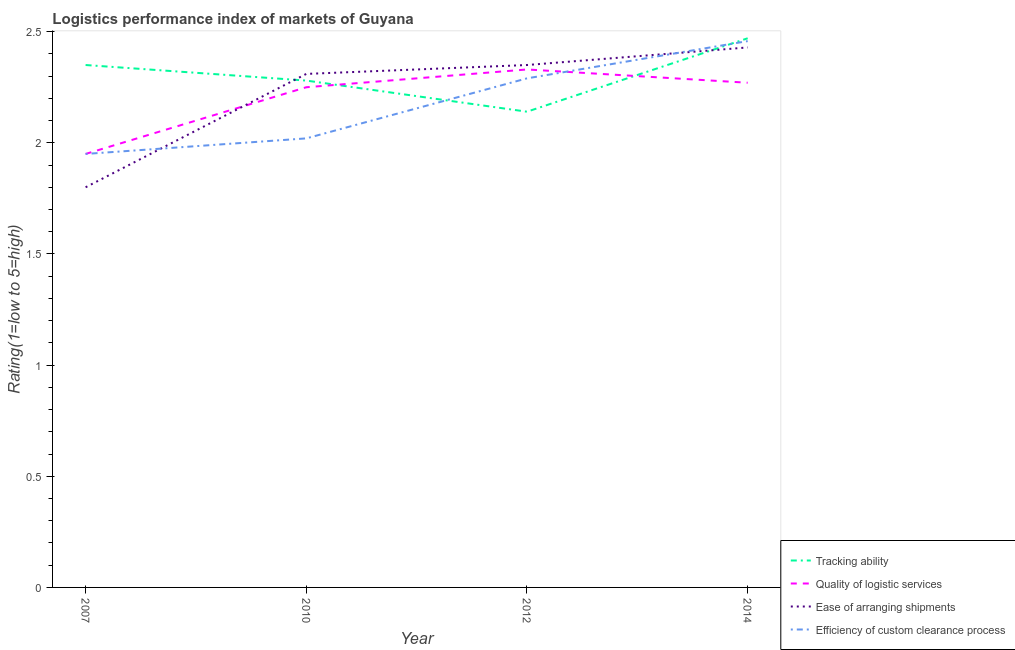What is the lpi rating of quality of logistic services in 2007?
Provide a succinct answer. 1.95. Across all years, what is the maximum lpi rating of efficiency of custom clearance process?
Your answer should be compact. 2.46. Across all years, what is the minimum lpi rating of efficiency of custom clearance process?
Offer a very short reply. 1.95. In which year was the lpi rating of efficiency of custom clearance process maximum?
Your response must be concise. 2014. In which year was the lpi rating of quality of logistic services minimum?
Offer a terse response. 2007. What is the total lpi rating of ease of arranging shipments in the graph?
Offer a very short reply. 8.89. What is the difference between the lpi rating of efficiency of custom clearance process in 2007 and that in 2012?
Keep it short and to the point. -0.34. What is the difference between the lpi rating of efficiency of custom clearance process in 2014 and the lpi rating of tracking ability in 2010?
Your response must be concise. 0.18. What is the average lpi rating of ease of arranging shipments per year?
Provide a short and direct response. 2.22. In the year 2010, what is the difference between the lpi rating of tracking ability and lpi rating of ease of arranging shipments?
Offer a very short reply. -0.03. What is the ratio of the lpi rating of ease of arranging shipments in 2007 to that in 2012?
Your answer should be compact. 0.77. Is the lpi rating of efficiency of custom clearance process in 2012 less than that in 2014?
Offer a terse response. Yes. Is the difference between the lpi rating of quality of logistic services in 2007 and 2014 greater than the difference between the lpi rating of ease of arranging shipments in 2007 and 2014?
Give a very brief answer. Yes. What is the difference between the highest and the second highest lpi rating of quality of logistic services?
Your answer should be compact. 0.06. What is the difference between the highest and the lowest lpi rating of tracking ability?
Your answer should be very brief. 0.33. In how many years, is the lpi rating of quality of logistic services greater than the average lpi rating of quality of logistic services taken over all years?
Offer a terse response. 3. Is it the case that in every year, the sum of the lpi rating of tracking ability and lpi rating of quality of logistic services is greater than the lpi rating of ease of arranging shipments?
Offer a very short reply. Yes. Does the lpi rating of efficiency of custom clearance process monotonically increase over the years?
Give a very brief answer. Yes. What is the difference between two consecutive major ticks on the Y-axis?
Provide a succinct answer. 0.5. Does the graph contain grids?
Offer a very short reply. No. Where does the legend appear in the graph?
Your answer should be compact. Bottom right. How many legend labels are there?
Your answer should be very brief. 4. How are the legend labels stacked?
Give a very brief answer. Vertical. What is the title of the graph?
Ensure brevity in your answer.  Logistics performance index of markets of Guyana. What is the label or title of the Y-axis?
Your answer should be very brief. Rating(1=low to 5=high). What is the Rating(1=low to 5=high) of Tracking ability in 2007?
Give a very brief answer. 2.35. What is the Rating(1=low to 5=high) of Quality of logistic services in 2007?
Keep it short and to the point. 1.95. What is the Rating(1=low to 5=high) in Efficiency of custom clearance process in 2007?
Offer a very short reply. 1.95. What is the Rating(1=low to 5=high) of Tracking ability in 2010?
Your answer should be compact. 2.28. What is the Rating(1=low to 5=high) in Quality of logistic services in 2010?
Ensure brevity in your answer.  2.25. What is the Rating(1=low to 5=high) in Ease of arranging shipments in 2010?
Ensure brevity in your answer.  2.31. What is the Rating(1=low to 5=high) of Efficiency of custom clearance process in 2010?
Offer a very short reply. 2.02. What is the Rating(1=low to 5=high) in Tracking ability in 2012?
Give a very brief answer. 2.14. What is the Rating(1=low to 5=high) in Quality of logistic services in 2012?
Provide a short and direct response. 2.33. What is the Rating(1=low to 5=high) in Ease of arranging shipments in 2012?
Give a very brief answer. 2.35. What is the Rating(1=low to 5=high) in Efficiency of custom clearance process in 2012?
Give a very brief answer. 2.29. What is the Rating(1=low to 5=high) of Tracking ability in 2014?
Offer a terse response. 2.47. What is the Rating(1=low to 5=high) of Quality of logistic services in 2014?
Offer a terse response. 2.27. What is the Rating(1=low to 5=high) of Ease of arranging shipments in 2014?
Keep it short and to the point. 2.43. What is the Rating(1=low to 5=high) of Efficiency of custom clearance process in 2014?
Your answer should be very brief. 2.46. Across all years, what is the maximum Rating(1=low to 5=high) in Tracking ability?
Ensure brevity in your answer.  2.47. Across all years, what is the maximum Rating(1=low to 5=high) of Quality of logistic services?
Your response must be concise. 2.33. Across all years, what is the maximum Rating(1=low to 5=high) in Ease of arranging shipments?
Give a very brief answer. 2.43. Across all years, what is the maximum Rating(1=low to 5=high) of Efficiency of custom clearance process?
Ensure brevity in your answer.  2.46. Across all years, what is the minimum Rating(1=low to 5=high) of Tracking ability?
Provide a succinct answer. 2.14. Across all years, what is the minimum Rating(1=low to 5=high) of Quality of logistic services?
Give a very brief answer. 1.95. Across all years, what is the minimum Rating(1=low to 5=high) of Efficiency of custom clearance process?
Provide a succinct answer. 1.95. What is the total Rating(1=low to 5=high) in Tracking ability in the graph?
Provide a short and direct response. 9.24. What is the total Rating(1=low to 5=high) in Quality of logistic services in the graph?
Ensure brevity in your answer.  8.8. What is the total Rating(1=low to 5=high) in Ease of arranging shipments in the graph?
Offer a very short reply. 8.89. What is the total Rating(1=low to 5=high) in Efficiency of custom clearance process in the graph?
Provide a succinct answer. 8.72. What is the difference between the Rating(1=low to 5=high) of Tracking ability in 2007 and that in 2010?
Offer a very short reply. 0.07. What is the difference between the Rating(1=low to 5=high) of Ease of arranging shipments in 2007 and that in 2010?
Keep it short and to the point. -0.51. What is the difference between the Rating(1=low to 5=high) of Efficiency of custom clearance process in 2007 and that in 2010?
Make the answer very short. -0.07. What is the difference between the Rating(1=low to 5=high) in Tracking ability in 2007 and that in 2012?
Offer a very short reply. 0.21. What is the difference between the Rating(1=low to 5=high) in Quality of logistic services in 2007 and that in 2012?
Offer a terse response. -0.38. What is the difference between the Rating(1=low to 5=high) of Ease of arranging shipments in 2007 and that in 2012?
Make the answer very short. -0.55. What is the difference between the Rating(1=low to 5=high) in Efficiency of custom clearance process in 2007 and that in 2012?
Your answer should be very brief. -0.34. What is the difference between the Rating(1=low to 5=high) of Tracking ability in 2007 and that in 2014?
Offer a very short reply. -0.12. What is the difference between the Rating(1=low to 5=high) in Quality of logistic services in 2007 and that in 2014?
Your answer should be very brief. -0.32. What is the difference between the Rating(1=low to 5=high) in Ease of arranging shipments in 2007 and that in 2014?
Offer a terse response. -0.63. What is the difference between the Rating(1=low to 5=high) of Efficiency of custom clearance process in 2007 and that in 2014?
Ensure brevity in your answer.  -0.51. What is the difference between the Rating(1=low to 5=high) of Tracking ability in 2010 and that in 2012?
Offer a very short reply. 0.14. What is the difference between the Rating(1=low to 5=high) in Quality of logistic services in 2010 and that in 2012?
Offer a very short reply. -0.08. What is the difference between the Rating(1=low to 5=high) of Ease of arranging shipments in 2010 and that in 2012?
Offer a very short reply. -0.04. What is the difference between the Rating(1=low to 5=high) of Efficiency of custom clearance process in 2010 and that in 2012?
Your answer should be compact. -0.27. What is the difference between the Rating(1=low to 5=high) in Tracking ability in 2010 and that in 2014?
Give a very brief answer. -0.19. What is the difference between the Rating(1=low to 5=high) in Quality of logistic services in 2010 and that in 2014?
Ensure brevity in your answer.  -0.02. What is the difference between the Rating(1=low to 5=high) in Ease of arranging shipments in 2010 and that in 2014?
Provide a short and direct response. -0.12. What is the difference between the Rating(1=low to 5=high) in Efficiency of custom clearance process in 2010 and that in 2014?
Your answer should be compact. -0.44. What is the difference between the Rating(1=low to 5=high) of Tracking ability in 2012 and that in 2014?
Ensure brevity in your answer.  -0.33. What is the difference between the Rating(1=low to 5=high) of Quality of logistic services in 2012 and that in 2014?
Offer a very short reply. 0.06. What is the difference between the Rating(1=low to 5=high) of Ease of arranging shipments in 2012 and that in 2014?
Offer a very short reply. -0.08. What is the difference between the Rating(1=low to 5=high) of Efficiency of custom clearance process in 2012 and that in 2014?
Your answer should be compact. -0.17. What is the difference between the Rating(1=low to 5=high) of Tracking ability in 2007 and the Rating(1=low to 5=high) of Ease of arranging shipments in 2010?
Provide a succinct answer. 0.04. What is the difference between the Rating(1=low to 5=high) in Tracking ability in 2007 and the Rating(1=low to 5=high) in Efficiency of custom clearance process in 2010?
Your answer should be very brief. 0.33. What is the difference between the Rating(1=low to 5=high) in Quality of logistic services in 2007 and the Rating(1=low to 5=high) in Ease of arranging shipments in 2010?
Provide a succinct answer. -0.36. What is the difference between the Rating(1=low to 5=high) of Quality of logistic services in 2007 and the Rating(1=low to 5=high) of Efficiency of custom clearance process in 2010?
Ensure brevity in your answer.  -0.07. What is the difference between the Rating(1=low to 5=high) of Ease of arranging shipments in 2007 and the Rating(1=low to 5=high) of Efficiency of custom clearance process in 2010?
Provide a short and direct response. -0.22. What is the difference between the Rating(1=low to 5=high) in Quality of logistic services in 2007 and the Rating(1=low to 5=high) in Ease of arranging shipments in 2012?
Make the answer very short. -0.4. What is the difference between the Rating(1=low to 5=high) in Quality of logistic services in 2007 and the Rating(1=low to 5=high) in Efficiency of custom clearance process in 2012?
Give a very brief answer. -0.34. What is the difference between the Rating(1=low to 5=high) of Ease of arranging shipments in 2007 and the Rating(1=low to 5=high) of Efficiency of custom clearance process in 2012?
Offer a very short reply. -0.49. What is the difference between the Rating(1=low to 5=high) in Tracking ability in 2007 and the Rating(1=low to 5=high) in Quality of logistic services in 2014?
Your answer should be compact. 0.08. What is the difference between the Rating(1=low to 5=high) of Tracking ability in 2007 and the Rating(1=low to 5=high) of Ease of arranging shipments in 2014?
Your answer should be compact. -0.08. What is the difference between the Rating(1=low to 5=high) of Tracking ability in 2007 and the Rating(1=low to 5=high) of Efficiency of custom clearance process in 2014?
Your answer should be very brief. -0.11. What is the difference between the Rating(1=low to 5=high) in Quality of logistic services in 2007 and the Rating(1=low to 5=high) in Ease of arranging shipments in 2014?
Offer a very short reply. -0.48. What is the difference between the Rating(1=low to 5=high) in Quality of logistic services in 2007 and the Rating(1=low to 5=high) in Efficiency of custom clearance process in 2014?
Your response must be concise. -0.51. What is the difference between the Rating(1=low to 5=high) of Ease of arranging shipments in 2007 and the Rating(1=low to 5=high) of Efficiency of custom clearance process in 2014?
Your answer should be very brief. -0.66. What is the difference between the Rating(1=low to 5=high) in Tracking ability in 2010 and the Rating(1=low to 5=high) in Ease of arranging shipments in 2012?
Your response must be concise. -0.07. What is the difference between the Rating(1=low to 5=high) in Tracking ability in 2010 and the Rating(1=low to 5=high) in Efficiency of custom clearance process in 2012?
Keep it short and to the point. -0.01. What is the difference between the Rating(1=low to 5=high) of Quality of logistic services in 2010 and the Rating(1=low to 5=high) of Efficiency of custom clearance process in 2012?
Keep it short and to the point. -0.04. What is the difference between the Rating(1=low to 5=high) of Tracking ability in 2010 and the Rating(1=low to 5=high) of Quality of logistic services in 2014?
Your response must be concise. 0.01. What is the difference between the Rating(1=low to 5=high) of Tracking ability in 2010 and the Rating(1=low to 5=high) of Ease of arranging shipments in 2014?
Keep it short and to the point. -0.15. What is the difference between the Rating(1=low to 5=high) in Tracking ability in 2010 and the Rating(1=low to 5=high) in Efficiency of custom clearance process in 2014?
Your answer should be very brief. -0.18. What is the difference between the Rating(1=low to 5=high) of Quality of logistic services in 2010 and the Rating(1=low to 5=high) of Ease of arranging shipments in 2014?
Offer a terse response. -0.18. What is the difference between the Rating(1=low to 5=high) in Quality of logistic services in 2010 and the Rating(1=low to 5=high) in Efficiency of custom clearance process in 2014?
Provide a succinct answer. -0.21. What is the difference between the Rating(1=low to 5=high) of Ease of arranging shipments in 2010 and the Rating(1=low to 5=high) of Efficiency of custom clearance process in 2014?
Your answer should be compact. -0.15. What is the difference between the Rating(1=low to 5=high) in Tracking ability in 2012 and the Rating(1=low to 5=high) in Quality of logistic services in 2014?
Your answer should be very brief. -0.13. What is the difference between the Rating(1=low to 5=high) of Tracking ability in 2012 and the Rating(1=low to 5=high) of Ease of arranging shipments in 2014?
Give a very brief answer. -0.29. What is the difference between the Rating(1=low to 5=high) of Tracking ability in 2012 and the Rating(1=low to 5=high) of Efficiency of custom clearance process in 2014?
Offer a terse response. -0.32. What is the difference between the Rating(1=low to 5=high) in Quality of logistic services in 2012 and the Rating(1=low to 5=high) in Ease of arranging shipments in 2014?
Give a very brief answer. -0.1. What is the difference between the Rating(1=low to 5=high) of Quality of logistic services in 2012 and the Rating(1=low to 5=high) of Efficiency of custom clearance process in 2014?
Ensure brevity in your answer.  -0.13. What is the difference between the Rating(1=low to 5=high) of Ease of arranging shipments in 2012 and the Rating(1=low to 5=high) of Efficiency of custom clearance process in 2014?
Ensure brevity in your answer.  -0.11. What is the average Rating(1=low to 5=high) of Tracking ability per year?
Keep it short and to the point. 2.31. What is the average Rating(1=low to 5=high) in Quality of logistic services per year?
Provide a short and direct response. 2.2. What is the average Rating(1=low to 5=high) of Ease of arranging shipments per year?
Your response must be concise. 2.22. What is the average Rating(1=low to 5=high) in Efficiency of custom clearance process per year?
Your answer should be very brief. 2.18. In the year 2007, what is the difference between the Rating(1=low to 5=high) of Tracking ability and Rating(1=low to 5=high) of Ease of arranging shipments?
Your answer should be compact. 0.55. In the year 2007, what is the difference between the Rating(1=low to 5=high) of Tracking ability and Rating(1=low to 5=high) of Efficiency of custom clearance process?
Offer a terse response. 0.4. In the year 2007, what is the difference between the Rating(1=low to 5=high) of Ease of arranging shipments and Rating(1=low to 5=high) of Efficiency of custom clearance process?
Your answer should be compact. -0.15. In the year 2010, what is the difference between the Rating(1=low to 5=high) in Tracking ability and Rating(1=low to 5=high) in Ease of arranging shipments?
Your answer should be very brief. -0.03. In the year 2010, what is the difference between the Rating(1=low to 5=high) of Tracking ability and Rating(1=low to 5=high) of Efficiency of custom clearance process?
Offer a terse response. 0.26. In the year 2010, what is the difference between the Rating(1=low to 5=high) of Quality of logistic services and Rating(1=low to 5=high) of Ease of arranging shipments?
Offer a terse response. -0.06. In the year 2010, what is the difference between the Rating(1=low to 5=high) in Quality of logistic services and Rating(1=low to 5=high) in Efficiency of custom clearance process?
Provide a short and direct response. 0.23. In the year 2010, what is the difference between the Rating(1=low to 5=high) in Ease of arranging shipments and Rating(1=low to 5=high) in Efficiency of custom clearance process?
Provide a succinct answer. 0.29. In the year 2012, what is the difference between the Rating(1=low to 5=high) of Tracking ability and Rating(1=low to 5=high) of Quality of logistic services?
Make the answer very short. -0.19. In the year 2012, what is the difference between the Rating(1=low to 5=high) of Tracking ability and Rating(1=low to 5=high) of Ease of arranging shipments?
Provide a short and direct response. -0.21. In the year 2012, what is the difference between the Rating(1=low to 5=high) in Quality of logistic services and Rating(1=low to 5=high) in Ease of arranging shipments?
Provide a succinct answer. -0.02. In the year 2012, what is the difference between the Rating(1=low to 5=high) in Ease of arranging shipments and Rating(1=low to 5=high) in Efficiency of custom clearance process?
Offer a terse response. 0.06. In the year 2014, what is the difference between the Rating(1=low to 5=high) in Tracking ability and Rating(1=low to 5=high) in Quality of logistic services?
Your answer should be compact. 0.2. In the year 2014, what is the difference between the Rating(1=low to 5=high) of Tracking ability and Rating(1=low to 5=high) of Ease of arranging shipments?
Make the answer very short. 0.04. In the year 2014, what is the difference between the Rating(1=low to 5=high) in Tracking ability and Rating(1=low to 5=high) in Efficiency of custom clearance process?
Keep it short and to the point. 0.01. In the year 2014, what is the difference between the Rating(1=low to 5=high) in Quality of logistic services and Rating(1=low to 5=high) in Ease of arranging shipments?
Your answer should be very brief. -0.16. In the year 2014, what is the difference between the Rating(1=low to 5=high) of Quality of logistic services and Rating(1=low to 5=high) of Efficiency of custom clearance process?
Your response must be concise. -0.19. In the year 2014, what is the difference between the Rating(1=low to 5=high) in Ease of arranging shipments and Rating(1=low to 5=high) in Efficiency of custom clearance process?
Provide a short and direct response. -0.03. What is the ratio of the Rating(1=low to 5=high) of Tracking ability in 2007 to that in 2010?
Offer a very short reply. 1.03. What is the ratio of the Rating(1=low to 5=high) in Quality of logistic services in 2007 to that in 2010?
Your answer should be very brief. 0.87. What is the ratio of the Rating(1=low to 5=high) in Ease of arranging shipments in 2007 to that in 2010?
Offer a terse response. 0.78. What is the ratio of the Rating(1=low to 5=high) of Efficiency of custom clearance process in 2007 to that in 2010?
Your answer should be compact. 0.97. What is the ratio of the Rating(1=low to 5=high) of Tracking ability in 2007 to that in 2012?
Your response must be concise. 1.1. What is the ratio of the Rating(1=low to 5=high) of Quality of logistic services in 2007 to that in 2012?
Offer a very short reply. 0.84. What is the ratio of the Rating(1=low to 5=high) of Ease of arranging shipments in 2007 to that in 2012?
Keep it short and to the point. 0.77. What is the ratio of the Rating(1=low to 5=high) of Efficiency of custom clearance process in 2007 to that in 2012?
Your answer should be compact. 0.85. What is the ratio of the Rating(1=low to 5=high) in Tracking ability in 2007 to that in 2014?
Your answer should be compact. 0.95. What is the ratio of the Rating(1=low to 5=high) of Quality of logistic services in 2007 to that in 2014?
Ensure brevity in your answer.  0.86. What is the ratio of the Rating(1=low to 5=high) in Ease of arranging shipments in 2007 to that in 2014?
Your answer should be compact. 0.74. What is the ratio of the Rating(1=low to 5=high) of Efficiency of custom clearance process in 2007 to that in 2014?
Make the answer very short. 0.79. What is the ratio of the Rating(1=low to 5=high) of Tracking ability in 2010 to that in 2012?
Provide a short and direct response. 1.07. What is the ratio of the Rating(1=low to 5=high) of Quality of logistic services in 2010 to that in 2012?
Give a very brief answer. 0.97. What is the ratio of the Rating(1=low to 5=high) in Efficiency of custom clearance process in 2010 to that in 2012?
Ensure brevity in your answer.  0.88. What is the ratio of the Rating(1=low to 5=high) in Tracking ability in 2010 to that in 2014?
Your answer should be very brief. 0.92. What is the ratio of the Rating(1=low to 5=high) in Ease of arranging shipments in 2010 to that in 2014?
Your answer should be compact. 0.95. What is the ratio of the Rating(1=low to 5=high) of Efficiency of custom clearance process in 2010 to that in 2014?
Give a very brief answer. 0.82. What is the ratio of the Rating(1=low to 5=high) of Tracking ability in 2012 to that in 2014?
Provide a short and direct response. 0.87. What is the ratio of the Rating(1=low to 5=high) of Quality of logistic services in 2012 to that in 2014?
Give a very brief answer. 1.03. What is the ratio of the Rating(1=low to 5=high) in Ease of arranging shipments in 2012 to that in 2014?
Your response must be concise. 0.97. What is the ratio of the Rating(1=low to 5=high) in Efficiency of custom clearance process in 2012 to that in 2014?
Your answer should be compact. 0.93. What is the difference between the highest and the second highest Rating(1=low to 5=high) in Tracking ability?
Offer a very short reply. 0.12. What is the difference between the highest and the second highest Rating(1=low to 5=high) of Quality of logistic services?
Offer a very short reply. 0.06. What is the difference between the highest and the second highest Rating(1=low to 5=high) in Ease of arranging shipments?
Keep it short and to the point. 0.08. What is the difference between the highest and the second highest Rating(1=low to 5=high) in Efficiency of custom clearance process?
Make the answer very short. 0.17. What is the difference between the highest and the lowest Rating(1=low to 5=high) of Tracking ability?
Keep it short and to the point. 0.33. What is the difference between the highest and the lowest Rating(1=low to 5=high) of Quality of logistic services?
Provide a short and direct response. 0.38. What is the difference between the highest and the lowest Rating(1=low to 5=high) in Ease of arranging shipments?
Offer a terse response. 0.63. What is the difference between the highest and the lowest Rating(1=low to 5=high) of Efficiency of custom clearance process?
Your answer should be very brief. 0.51. 